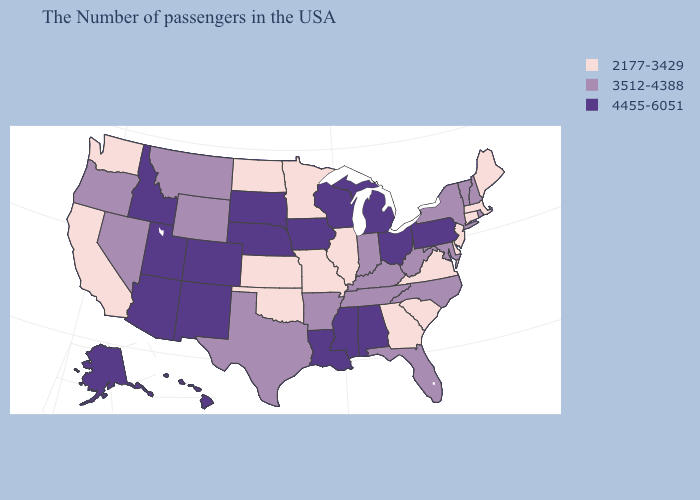What is the highest value in states that border West Virginia?
Keep it brief. 4455-6051. Does Minnesota have the same value as Florida?
Keep it brief. No. What is the highest value in the USA?
Answer briefly. 4455-6051. What is the value of Arkansas?
Write a very short answer. 3512-4388. Name the states that have a value in the range 2177-3429?
Concise answer only. Maine, Massachusetts, Connecticut, New Jersey, Delaware, Virginia, South Carolina, Georgia, Illinois, Missouri, Minnesota, Kansas, Oklahoma, North Dakota, California, Washington. What is the value of Texas?
Write a very short answer. 3512-4388. What is the lowest value in the South?
Keep it brief. 2177-3429. What is the value of Delaware?
Give a very brief answer. 2177-3429. Which states hav the highest value in the MidWest?
Answer briefly. Ohio, Michigan, Wisconsin, Iowa, Nebraska, South Dakota. Among the states that border Arizona , which have the lowest value?
Short answer required. California. Does Utah have the highest value in the West?
Answer briefly. Yes. How many symbols are there in the legend?
Give a very brief answer. 3. Does New York have a lower value than Louisiana?
Answer briefly. Yes. What is the value of Connecticut?
Short answer required. 2177-3429. Does Idaho have the highest value in the USA?
Answer briefly. Yes. 